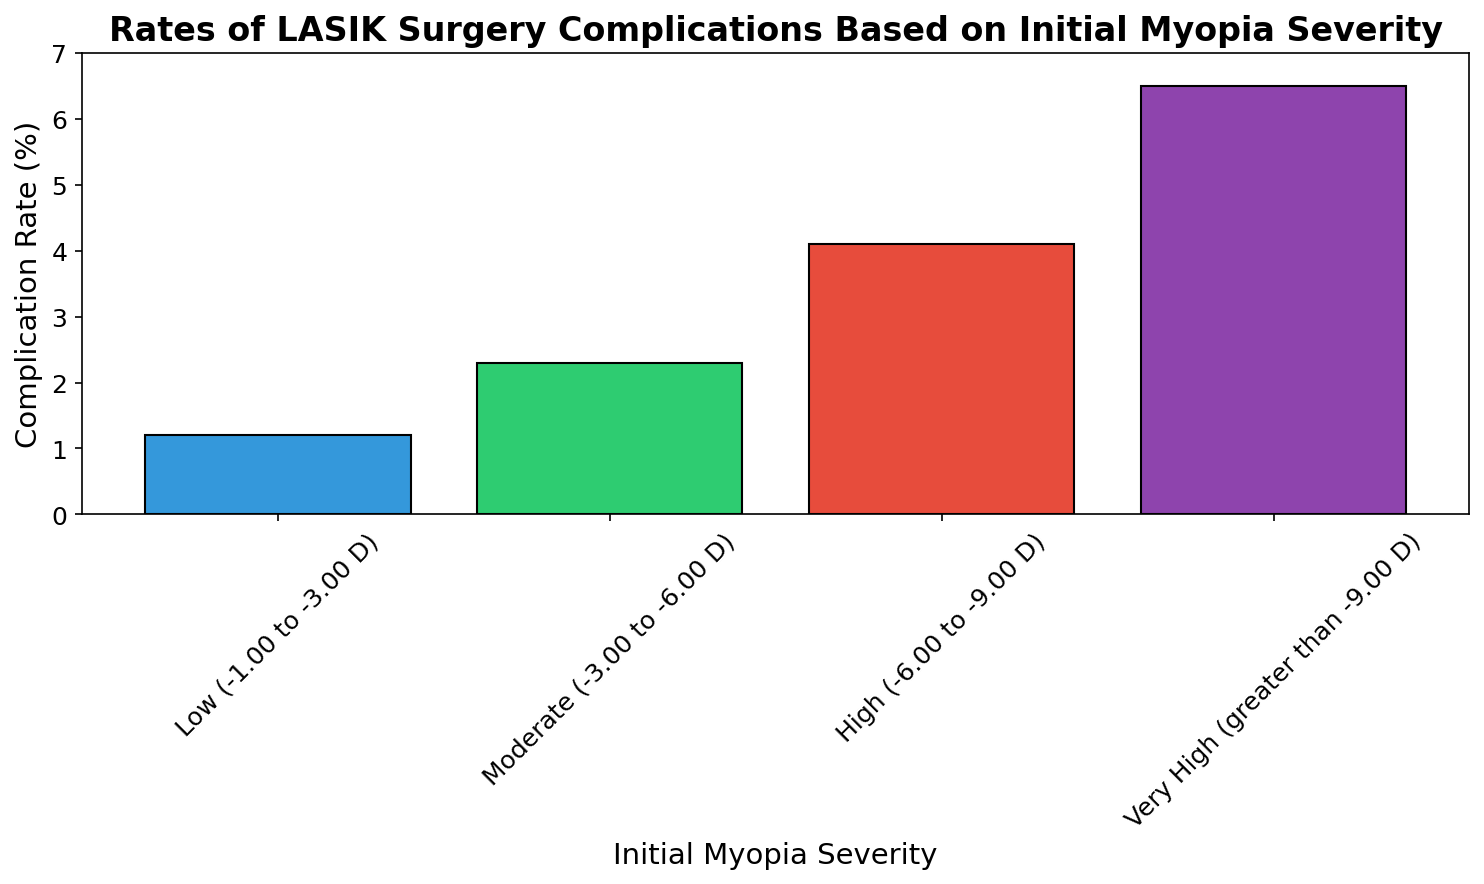What is the highest rate of LASIK surgery complications based on initial myopia severity? The highest rate is in the "Very High (greater than -9.00 D)" category. We can see that the bar corresponding to this category is taller compared to the others.
Answer: 6.5% Which initial myopia severity category has the lowest complication rate? The "Low (-1.00 to -3.00 D)" category has the lowest complication rate, as indicated by the shortest bar in the bar chart.
Answer: 1.2% How much higher is the complication rate for "High (-6.00 to -9.00 D)" compared to "Moderate (-3.00 to -6.00 D)"? To find the difference, subtract the complication rate of "Moderate" from "High": 4.1 - 2.3 = 1.8.
Answer: 1.8% What is the total complication rate if you sum up all categories? Add the complication rates of all categories: 1.2 + 2.3 + 4.1 + 6.5 = 14.1.
Answer: 14.1% Which category has a complication rate that is twice the rate of the "Low" category? The "Moderate (-3.00 to -6.00 D)" category has a complication rate of 2.3%, which is nearly twice the 1.2% complication rate of the "Low" category.
Answer: Moderate (-3.00 to -6.00 D) Is the complication rate for "Very High" myopia more than three times that of "Low" myopia? Calculate three times the "Low" complication rate (1.2 * 3 = 3.6) and compare it with "Very High" (6.5. Since 6.5 is greater than 3.6, the answer is yes.
Answer: Yes Which two myopia severity categories have complication rates that sum to approximately 3.5%? The complication rates for "Low" (1.2%) and "Moderate" (2.3%) sum to 3.5% (1.2 + 2.3 = 3.5).
Answer: Low (-1.00 to -3.00 D) and Moderate (-3.00 to -6.00 D) By how much does the complication rate increase as you move from "High" to "Very High" myopia severity? Subtract the "High" rate from the "Very High" rate: 6.5 - 4.1 = 2.4.
Answer: 2.4% What is the average complication rate across all categories? Add the complication rates (1.2 + 2.3 + 4.1 + 6.5) and divide by the number of categories (4): (1.2 + 2.3 + 4.1 + 6.5) / 4 = 3.525%.
Answer: 3.525% 